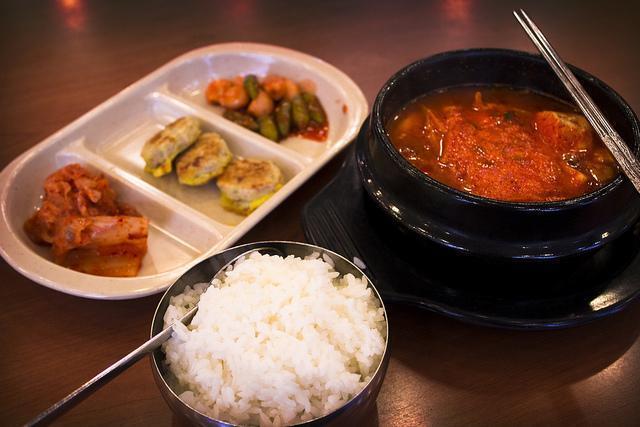How many sections are in the plate?
Give a very brief answer. 3. How many bowls are in the photo?
Give a very brief answer. 2. 